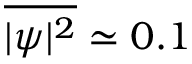Convert formula to latex. <formula><loc_0><loc_0><loc_500><loc_500>\overline { { | \psi | ^ { 2 } } } \simeq 0 . 1</formula> 